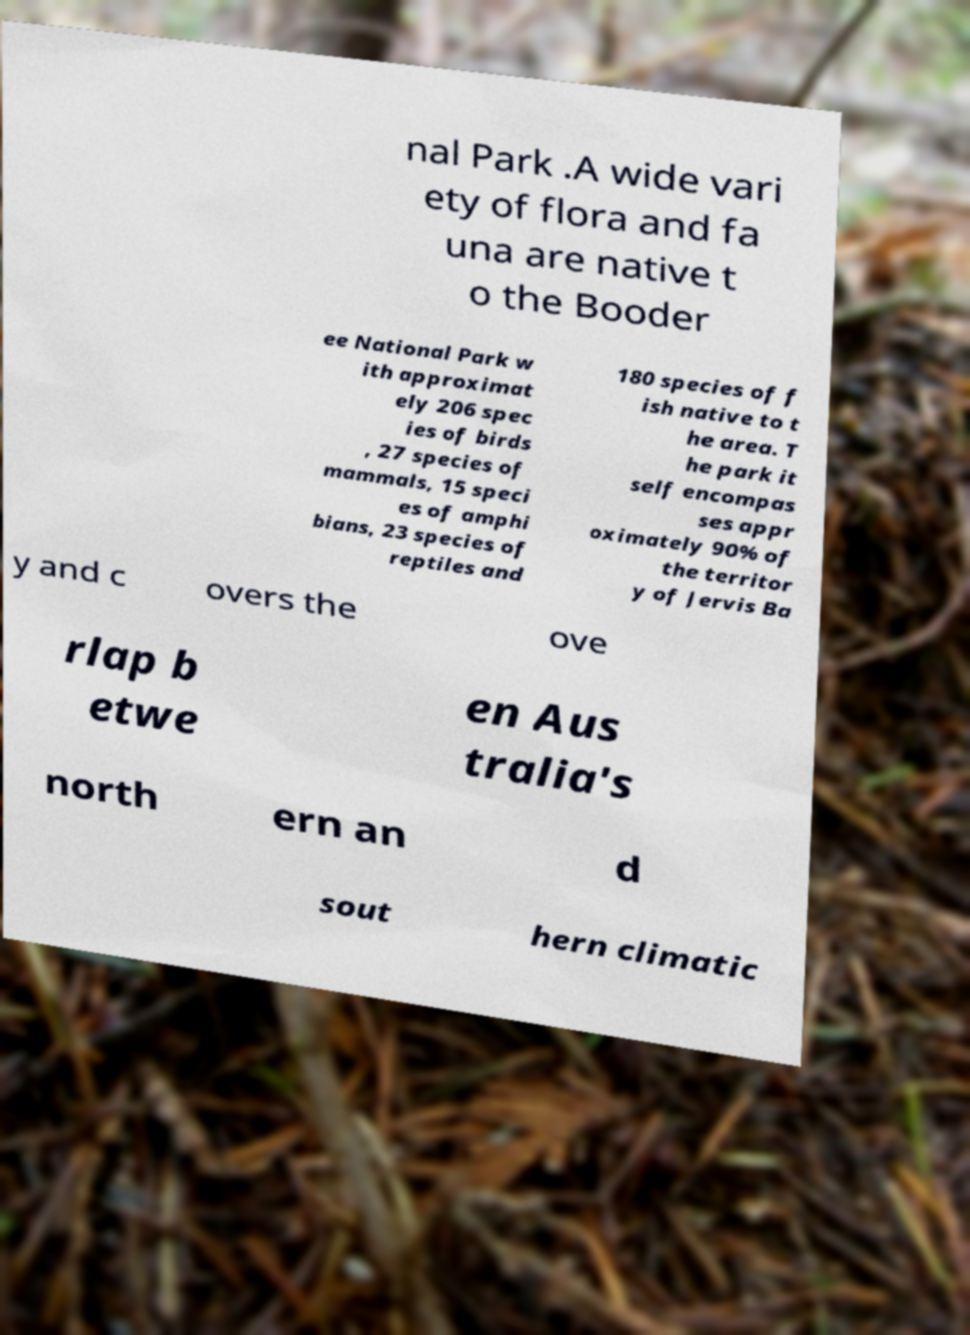What messages or text are displayed in this image? I need them in a readable, typed format. nal Park .A wide vari ety of flora and fa una are native t o the Booder ee National Park w ith approximat ely 206 spec ies of birds , 27 species of mammals, 15 speci es of amphi bians, 23 species of reptiles and 180 species of f ish native to t he area. T he park it self encompas ses appr oximately 90% of the territor y of Jervis Ba y and c overs the ove rlap b etwe en Aus tralia's north ern an d sout hern climatic 